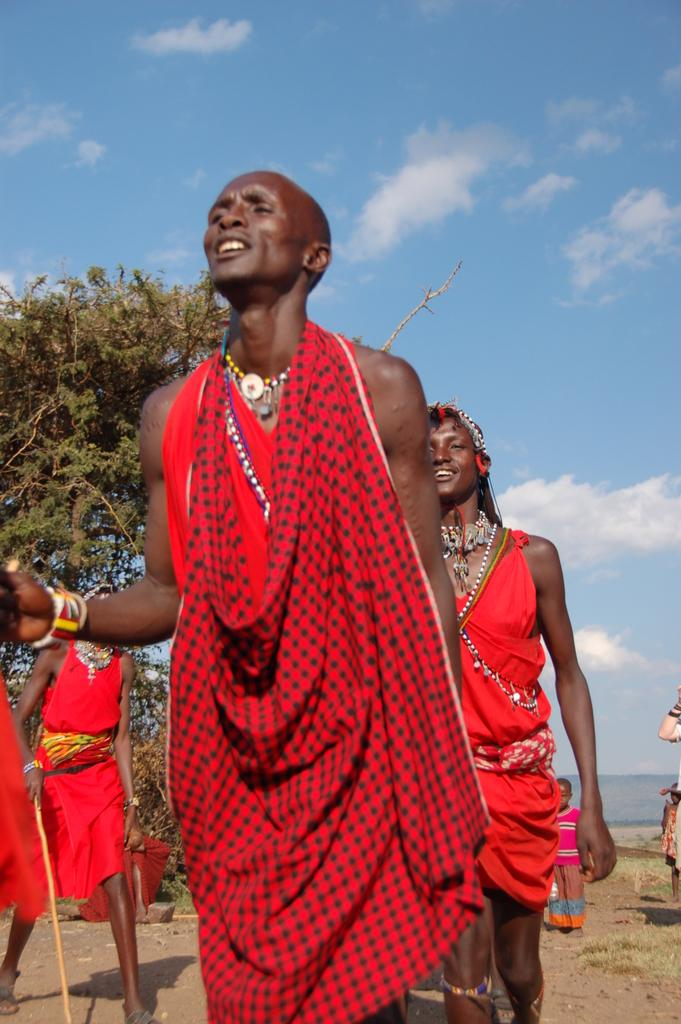What are the people in the image doing? The people in the image are on a path. Can you describe the person on the left side of the image? The person on the left side of the image is holding a stick. How would you describe the sky in the image? The sky in the image is blue and cloudy. What type of boot can be seen on the path in the image? There is no boot visible on the path in the image. 